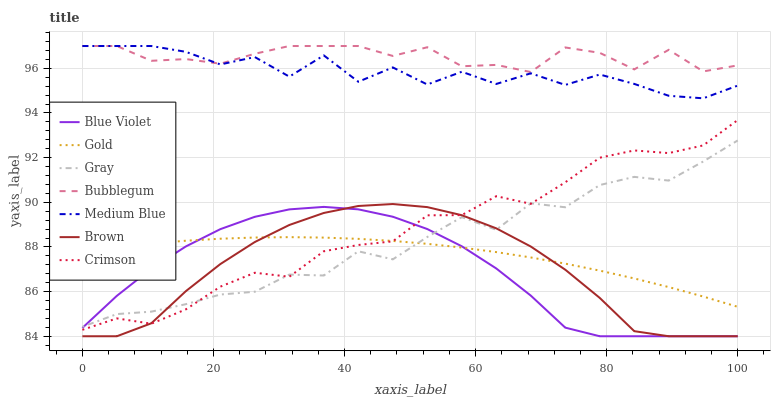Does Blue Violet have the minimum area under the curve?
Answer yes or no. Yes. Does Bubblegum have the maximum area under the curve?
Answer yes or no. Yes. Does Gold have the minimum area under the curve?
Answer yes or no. No. Does Gold have the maximum area under the curve?
Answer yes or no. No. Is Gold the smoothest?
Answer yes or no. Yes. Is Medium Blue the roughest?
Answer yes or no. Yes. Is Brown the smoothest?
Answer yes or no. No. Is Brown the roughest?
Answer yes or no. No. Does Brown have the lowest value?
Answer yes or no. Yes. Does Gold have the lowest value?
Answer yes or no. No. Does Bubblegum have the highest value?
Answer yes or no. Yes. Does Brown have the highest value?
Answer yes or no. No. Is Crimson less than Bubblegum?
Answer yes or no. Yes. Is Medium Blue greater than Crimson?
Answer yes or no. Yes. Does Gold intersect Brown?
Answer yes or no. Yes. Is Gold less than Brown?
Answer yes or no. No. Is Gold greater than Brown?
Answer yes or no. No. Does Crimson intersect Bubblegum?
Answer yes or no. No. 